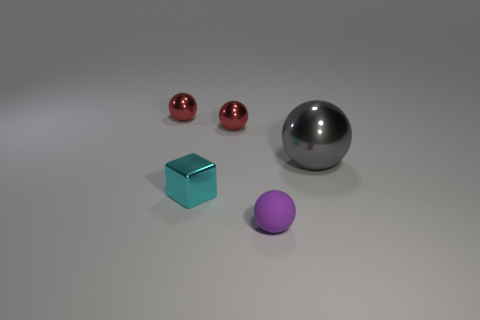Add 2 tiny red metallic spheres. How many objects exist? 7 Subtract all spheres. How many objects are left? 1 Add 4 metallic blocks. How many metallic blocks are left? 5 Add 2 small purple rubber things. How many small purple rubber things exist? 3 Subtract 0 green balls. How many objects are left? 5 Subtract all metallic balls. Subtract all big objects. How many objects are left? 1 